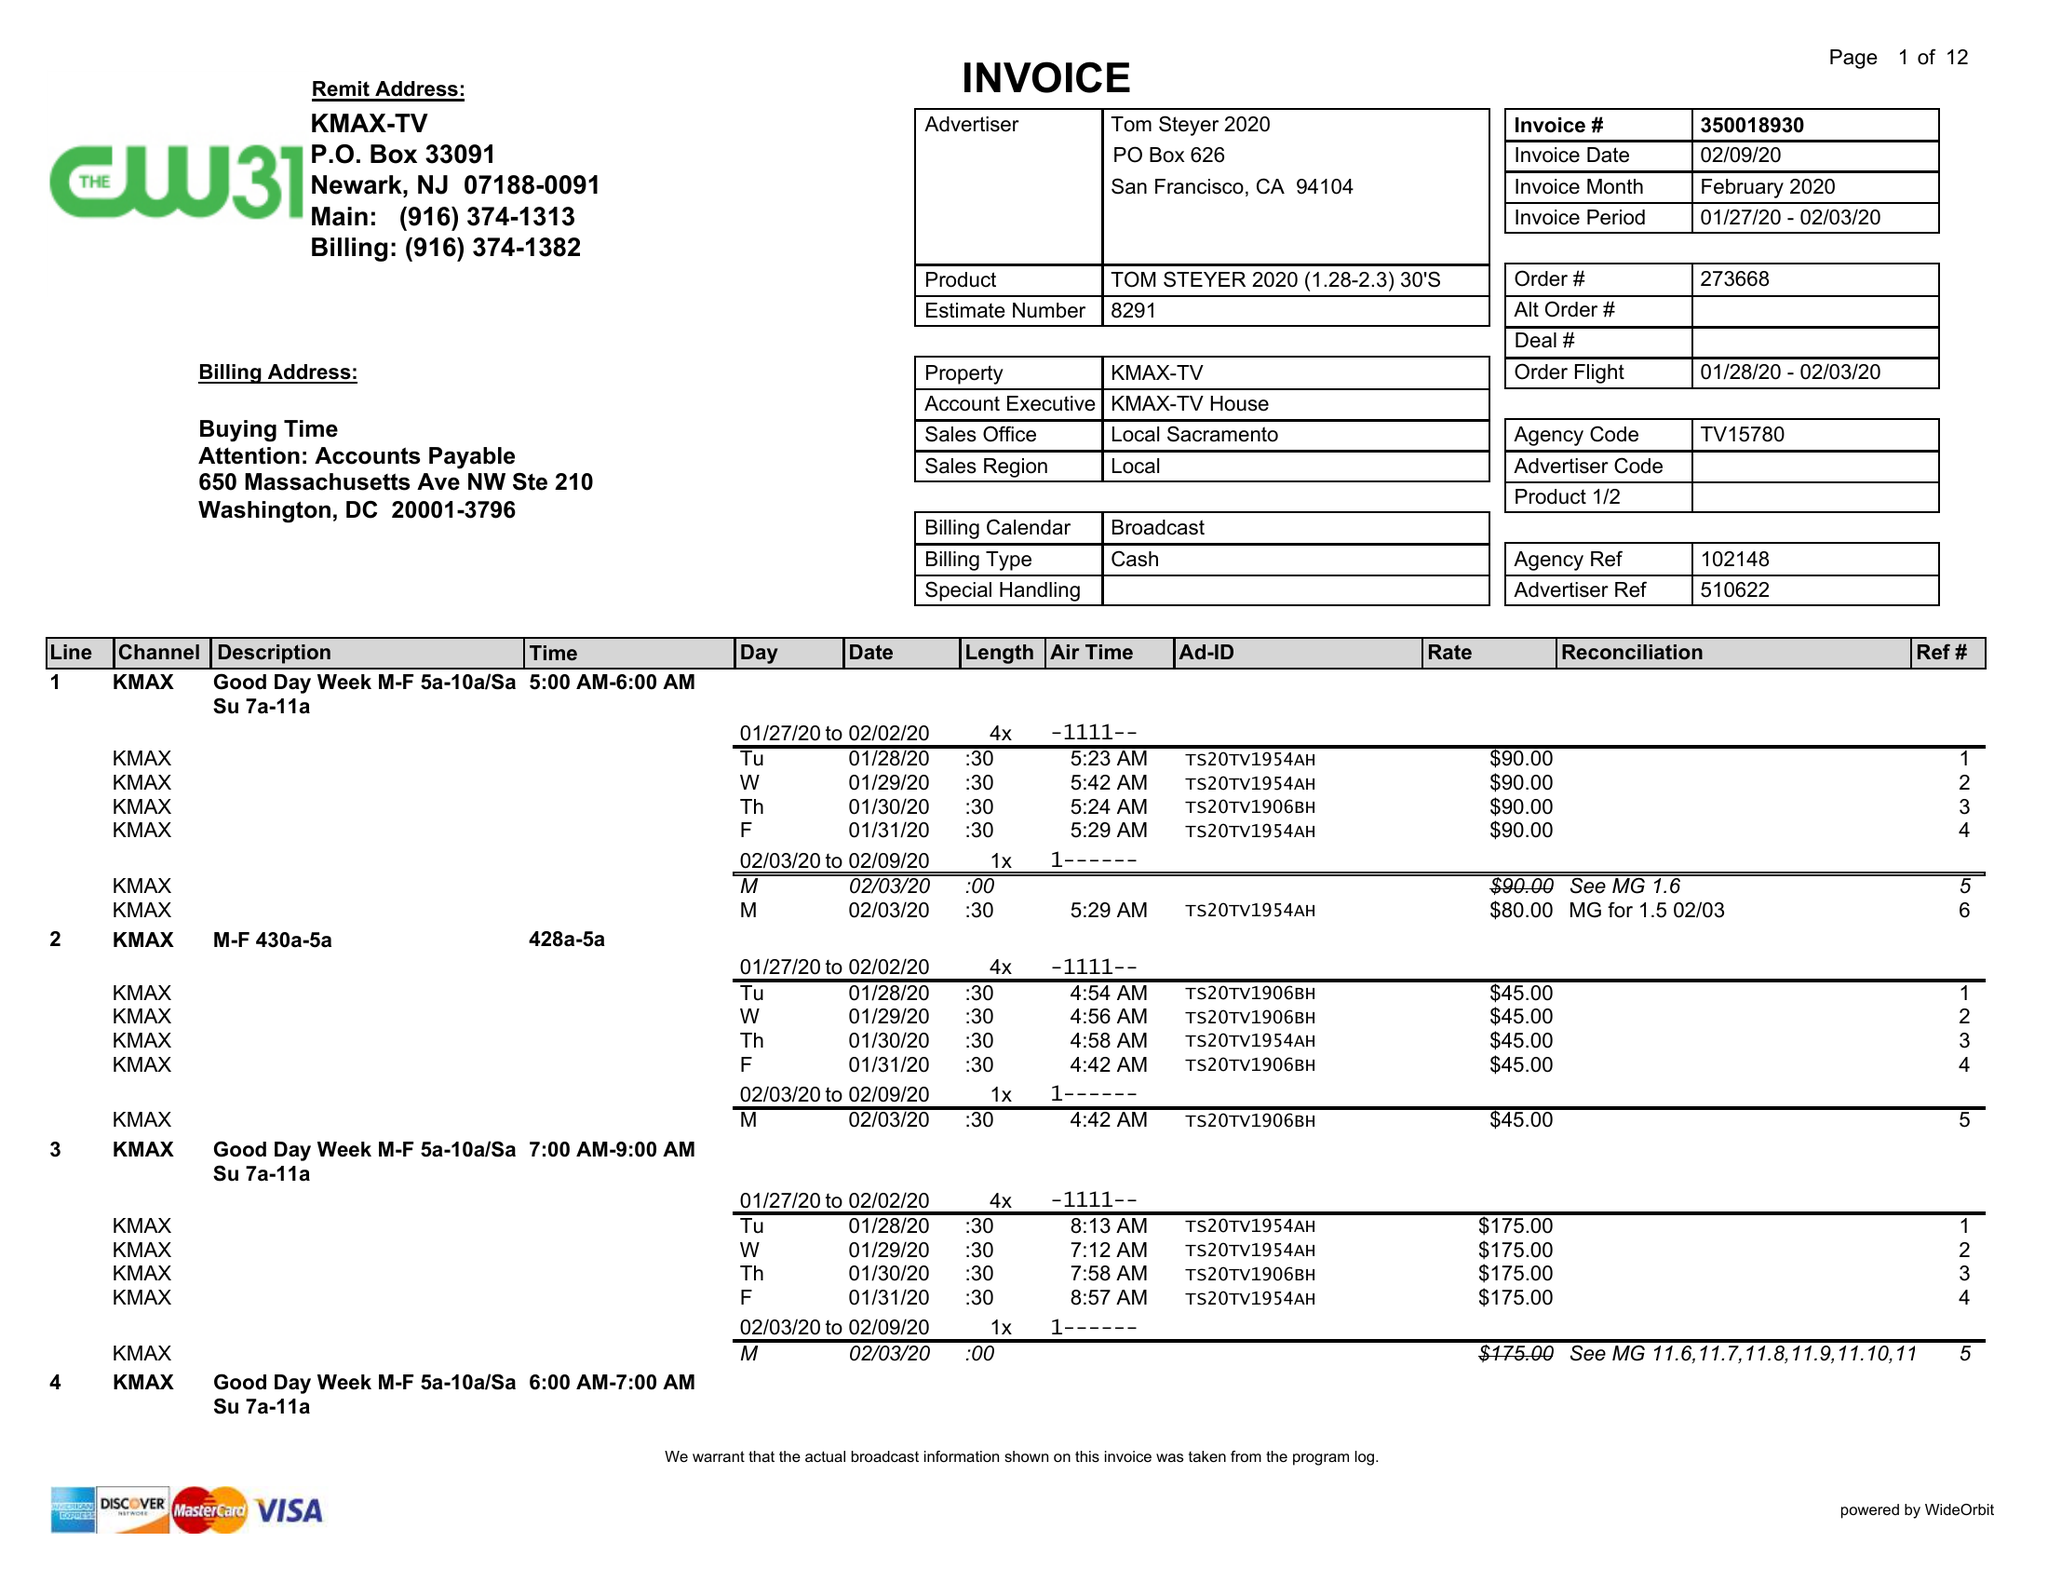What is the value for the advertiser?
Answer the question using a single word or phrase. TOM STEYER 2020 